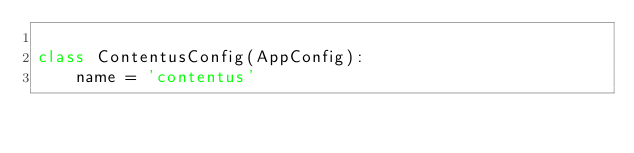<code> <loc_0><loc_0><loc_500><loc_500><_Python_>
class ContentusConfig(AppConfig):
    name = 'contentus'
</code> 